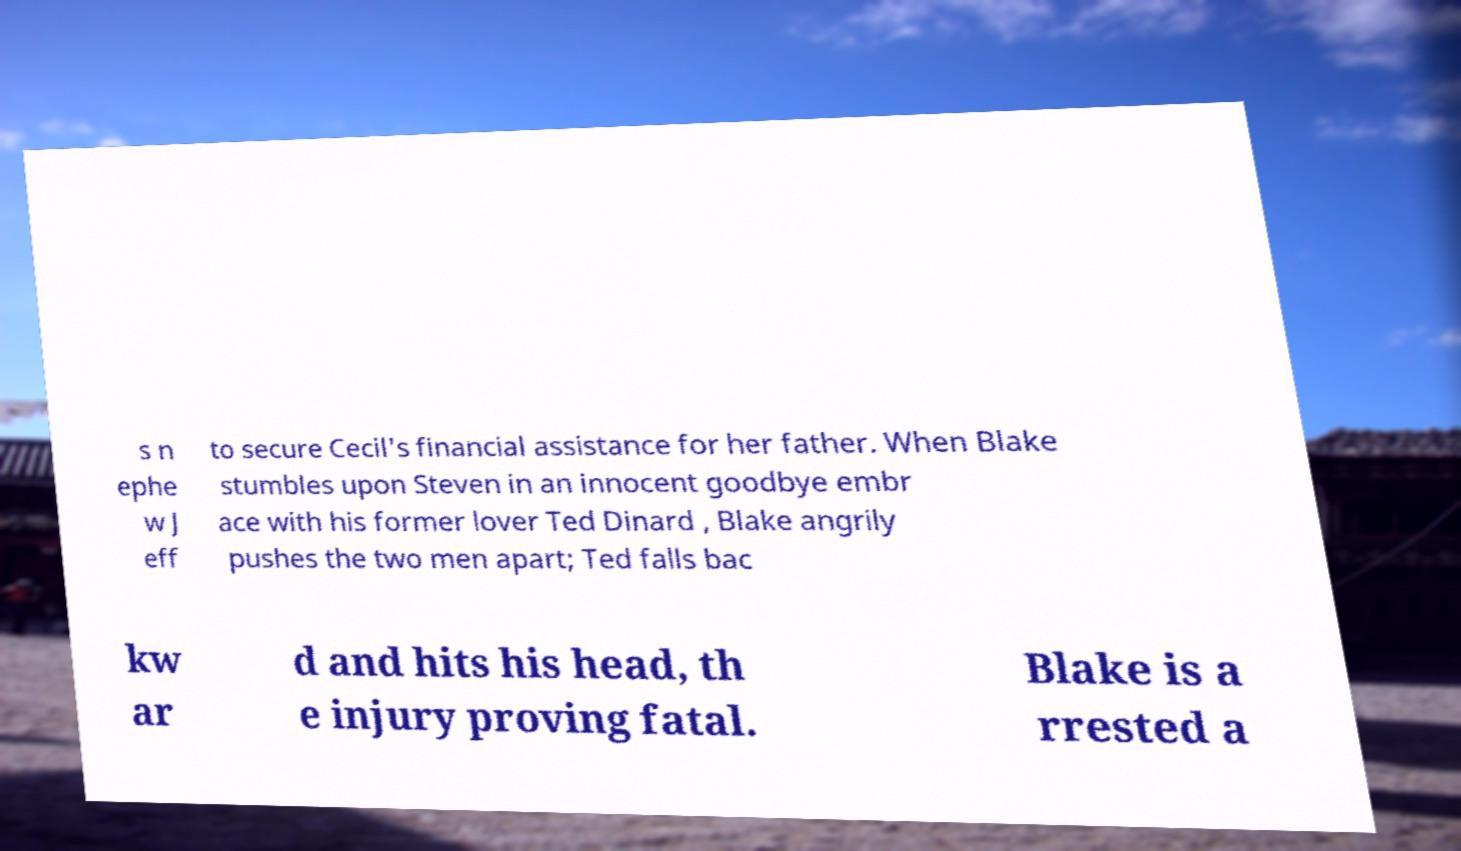Can you read and provide the text displayed in the image?This photo seems to have some interesting text. Can you extract and type it out for me? s n ephe w J eff to secure Cecil's financial assistance for her father. When Blake stumbles upon Steven in an innocent goodbye embr ace with his former lover Ted Dinard , Blake angrily pushes the two men apart; Ted falls bac kw ar d and hits his head, th e injury proving fatal. Blake is a rrested a 